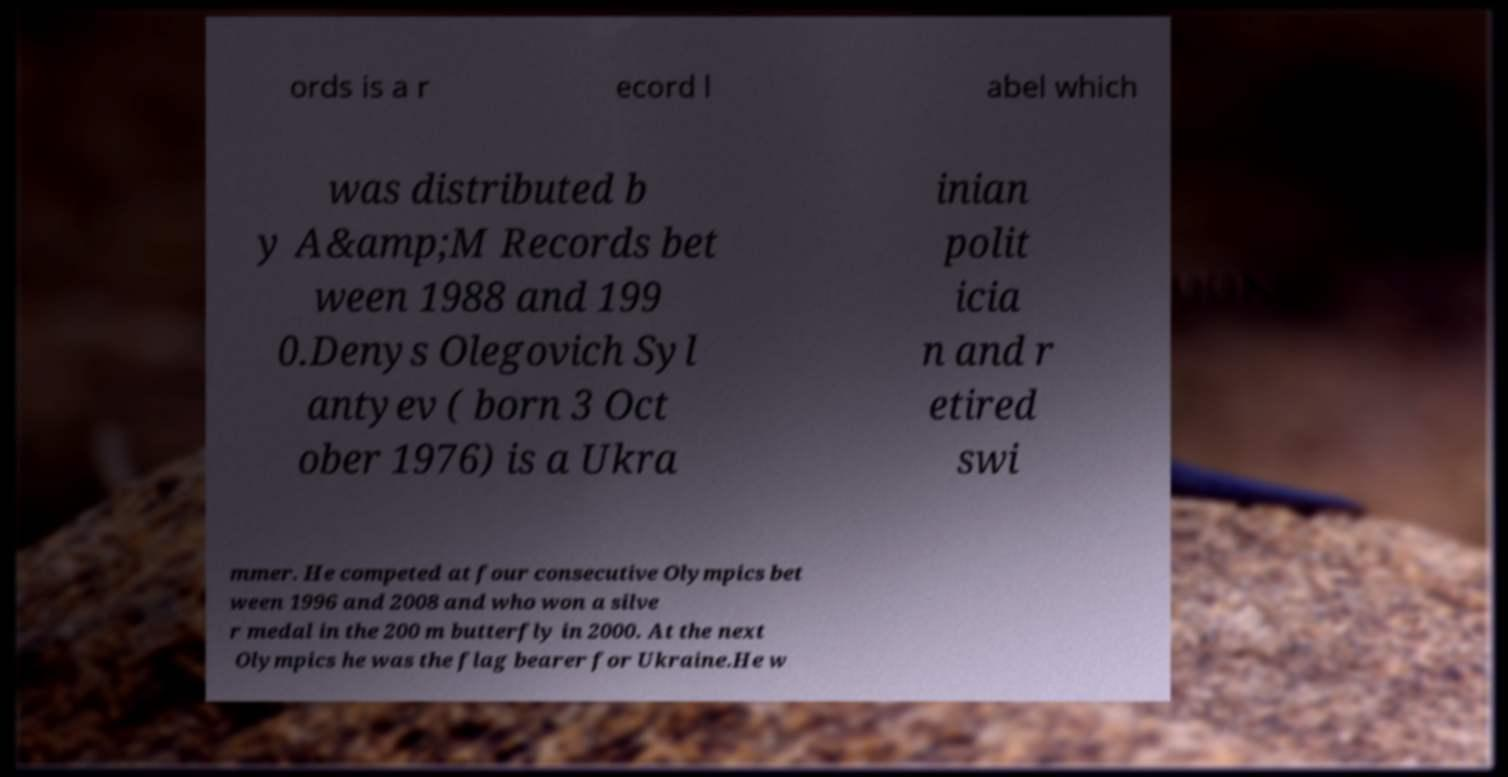What messages or text are displayed in this image? I need them in a readable, typed format. ords is a r ecord l abel which was distributed b y A&amp;M Records bet ween 1988 and 199 0.Denys Olegovich Syl antyev ( born 3 Oct ober 1976) is a Ukra inian polit icia n and r etired swi mmer. He competed at four consecutive Olympics bet ween 1996 and 2008 and who won a silve r medal in the 200 m butterfly in 2000. At the next Olympics he was the flag bearer for Ukraine.He w 